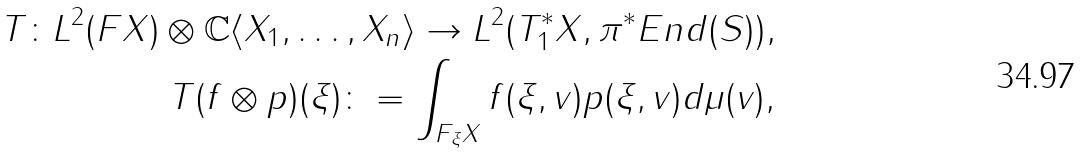Convert formula to latex. <formula><loc_0><loc_0><loc_500><loc_500>T \colon L ^ { 2 } ( F X ) \otimes \mathbb { C } \langle X _ { 1 } , \dots , X _ { n } \rangle \to L ^ { 2 } ( T ^ { * } _ { 1 } X , \pi ^ { * } E n d ( S ) ) , \\ T ( f \otimes p ) ( \xi ) \colon = \int _ { F _ { \xi } X } f ( \xi , v ) p ( \xi , v ) d \mu ( v ) ,</formula> 